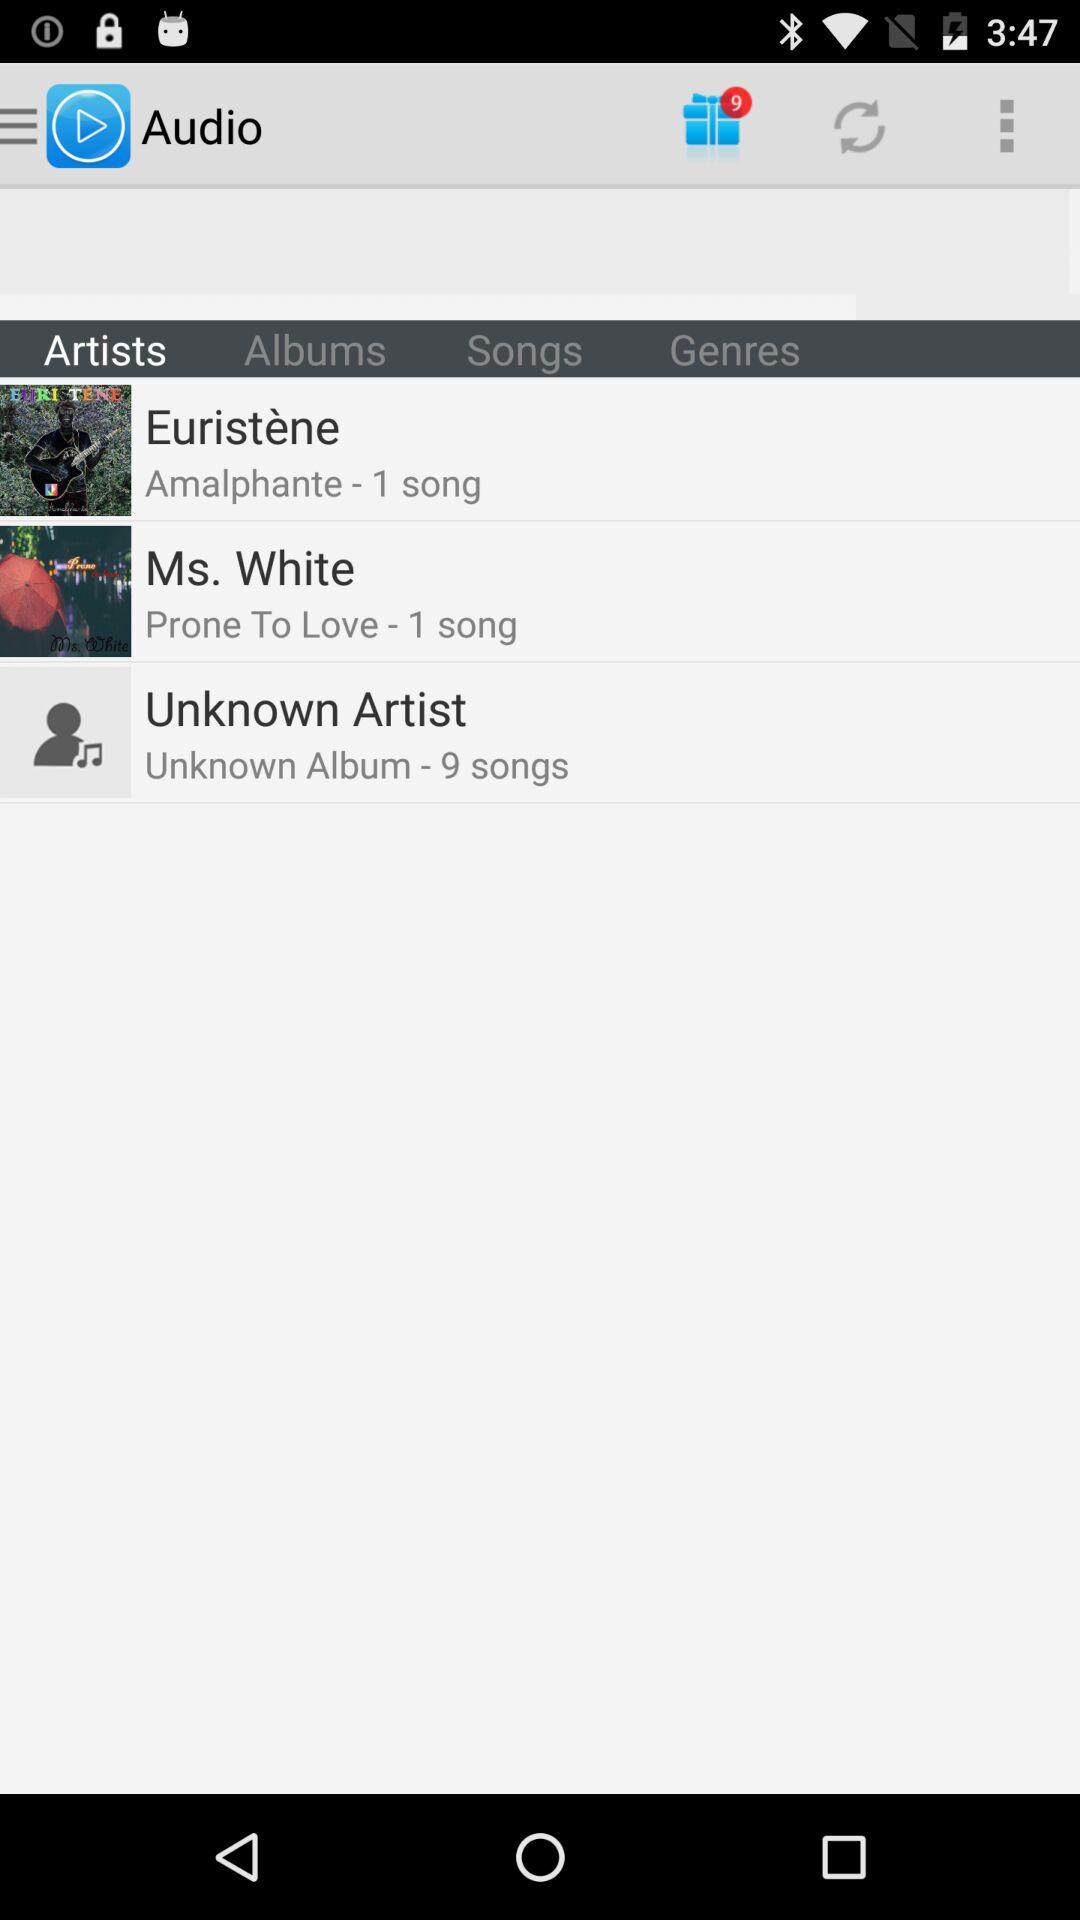Which tab is selected? The selected tab is "Artists". 